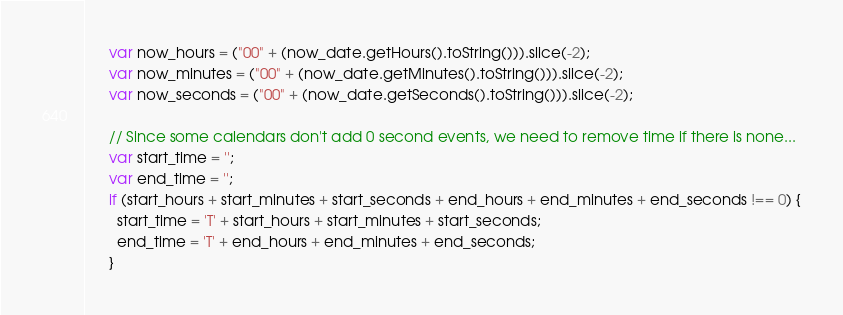<code> <loc_0><loc_0><loc_500><loc_500><_JavaScript_>      var now_hours = ("00" + (now_date.getHours().toString())).slice(-2);
      var now_minutes = ("00" + (now_date.getMinutes().toString())).slice(-2);
      var now_seconds = ("00" + (now_date.getSeconds().toString())).slice(-2);

      // Since some calendars don't add 0 second events, we need to remove time if there is none...
      var start_time = '';
      var end_time = '';
      if (start_hours + start_minutes + start_seconds + end_hours + end_minutes + end_seconds !== 0) {
        start_time = 'T' + start_hours + start_minutes + start_seconds;
        end_time = 'T' + end_hours + end_minutes + end_seconds;
      }</code> 